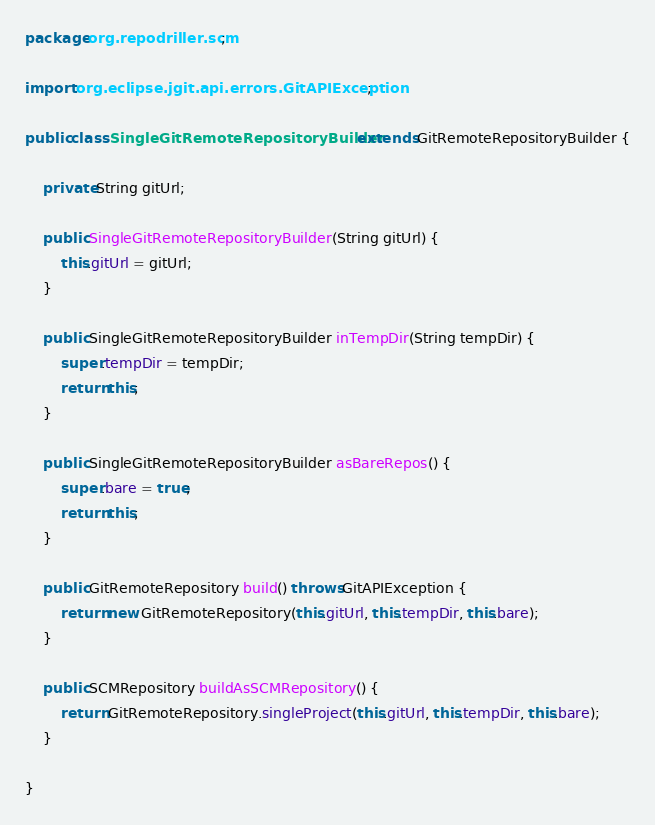<code> <loc_0><loc_0><loc_500><loc_500><_Java_>package org.repodriller.scm;

import org.eclipse.jgit.api.errors.GitAPIException;

public class SingleGitRemoteRepositoryBuilder extends GitRemoteRepositoryBuilder {

	private String gitUrl;
	
	public SingleGitRemoteRepositoryBuilder(String gitUrl) {
		this.gitUrl = gitUrl;
	}
	
	public SingleGitRemoteRepositoryBuilder inTempDir(String tempDir) {
		super.tempDir = tempDir;
		return this;
	}

	public SingleGitRemoteRepositoryBuilder asBareRepos() {
		super.bare = true;
		return this;
	}

	public GitRemoteRepository build() throws GitAPIException {
		return new GitRemoteRepository(this.gitUrl, this.tempDir, this.bare);
	}

	public SCMRepository buildAsSCMRepository() {
		return GitRemoteRepository.singleProject(this.gitUrl, this.tempDir, this.bare);
	}

}</code> 